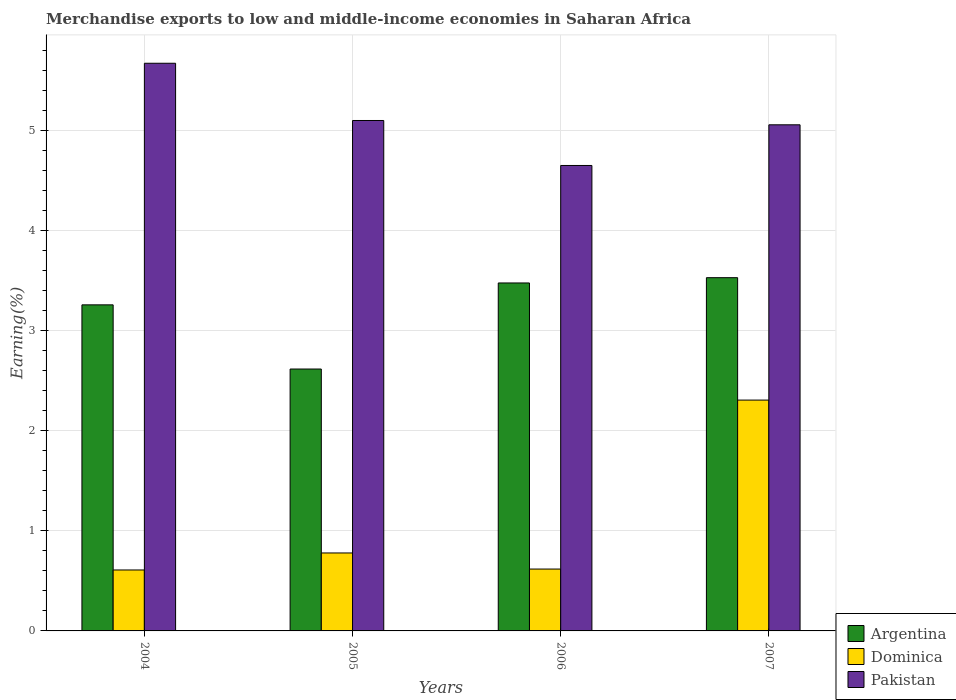How many different coloured bars are there?
Provide a succinct answer. 3. Are the number of bars per tick equal to the number of legend labels?
Keep it short and to the point. Yes. Are the number of bars on each tick of the X-axis equal?
Offer a very short reply. Yes. How many bars are there on the 1st tick from the left?
Your response must be concise. 3. In how many cases, is the number of bars for a given year not equal to the number of legend labels?
Provide a short and direct response. 0. What is the percentage of amount earned from merchandise exports in Pakistan in 2005?
Offer a very short reply. 5.1. Across all years, what is the maximum percentage of amount earned from merchandise exports in Pakistan?
Provide a short and direct response. 5.68. Across all years, what is the minimum percentage of amount earned from merchandise exports in Pakistan?
Your response must be concise. 4.66. In which year was the percentage of amount earned from merchandise exports in Argentina minimum?
Offer a very short reply. 2005. What is the total percentage of amount earned from merchandise exports in Pakistan in the graph?
Provide a short and direct response. 20.5. What is the difference between the percentage of amount earned from merchandise exports in Dominica in 2005 and that in 2006?
Give a very brief answer. 0.16. What is the difference between the percentage of amount earned from merchandise exports in Dominica in 2007 and the percentage of amount earned from merchandise exports in Pakistan in 2004?
Give a very brief answer. -3.37. What is the average percentage of amount earned from merchandise exports in Argentina per year?
Offer a terse response. 3.22. In the year 2007, what is the difference between the percentage of amount earned from merchandise exports in Pakistan and percentage of amount earned from merchandise exports in Argentina?
Give a very brief answer. 1.53. What is the ratio of the percentage of amount earned from merchandise exports in Dominica in 2005 to that in 2006?
Your answer should be very brief. 1.26. What is the difference between the highest and the second highest percentage of amount earned from merchandise exports in Pakistan?
Provide a succinct answer. 0.57. What is the difference between the highest and the lowest percentage of amount earned from merchandise exports in Argentina?
Provide a short and direct response. 0.91. Is the sum of the percentage of amount earned from merchandise exports in Pakistan in 2005 and 2007 greater than the maximum percentage of amount earned from merchandise exports in Argentina across all years?
Ensure brevity in your answer.  Yes. What does the 2nd bar from the left in 2007 represents?
Ensure brevity in your answer.  Dominica. What does the 1st bar from the right in 2007 represents?
Keep it short and to the point. Pakistan. Is it the case that in every year, the sum of the percentage of amount earned from merchandise exports in Dominica and percentage of amount earned from merchandise exports in Pakistan is greater than the percentage of amount earned from merchandise exports in Argentina?
Offer a very short reply. Yes. How many bars are there?
Offer a very short reply. 12. Are all the bars in the graph horizontal?
Provide a short and direct response. No. What is the difference between two consecutive major ticks on the Y-axis?
Offer a terse response. 1. Does the graph contain any zero values?
Offer a terse response. No. Does the graph contain grids?
Provide a succinct answer. Yes. How many legend labels are there?
Ensure brevity in your answer.  3. How are the legend labels stacked?
Ensure brevity in your answer.  Vertical. What is the title of the graph?
Keep it short and to the point. Merchandise exports to low and middle-income economies in Saharan Africa. Does "Spain" appear as one of the legend labels in the graph?
Ensure brevity in your answer.  No. What is the label or title of the Y-axis?
Give a very brief answer. Earning(%). What is the Earning(%) of Argentina in 2004?
Give a very brief answer. 3.26. What is the Earning(%) of Dominica in 2004?
Your response must be concise. 0.61. What is the Earning(%) of Pakistan in 2004?
Provide a short and direct response. 5.68. What is the Earning(%) in Argentina in 2005?
Your answer should be very brief. 2.62. What is the Earning(%) of Dominica in 2005?
Offer a terse response. 0.78. What is the Earning(%) of Pakistan in 2005?
Give a very brief answer. 5.1. What is the Earning(%) of Argentina in 2006?
Offer a very short reply. 3.48. What is the Earning(%) of Dominica in 2006?
Make the answer very short. 0.62. What is the Earning(%) of Pakistan in 2006?
Give a very brief answer. 4.66. What is the Earning(%) in Argentina in 2007?
Give a very brief answer. 3.53. What is the Earning(%) in Dominica in 2007?
Keep it short and to the point. 2.31. What is the Earning(%) in Pakistan in 2007?
Your answer should be compact. 5.06. Across all years, what is the maximum Earning(%) of Argentina?
Ensure brevity in your answer.  3.53. Across all years, what is the maximum Earning(%) of Dominica?
Ensure brevity in your answer.  2.31. Across all years, what is the maximum Earning(%) of Pakistan?
Keep it short and to the point. 5.68. Across all years, what is the minimum Earning(%) in Argentina?
Provide a succinct answer. 2.62. Across all years, what is the minimum Earning(%) in Dominica?
Your response must be concise. 0.61. Across all years, what is the minimum Earning(%) in Pakistan?
Your answer should be compact. 4.66. What is the total Earning(%) of Argentina in the graph?
Ensure brevity in your answer.  12.89. What is the total Earning(%) in Dominica in the graph?
Provide a short and direct response. 4.32. What is the total Earning(%) in Pakistan in the graph?
Your response must be concise. 20.5. What is the difference between the Earning(%) in Argentina in 2004 and that in 2005?
Make the answer very short. 0.64. What is the difference between the Earning(%) in Dominica in 2004 and that in 2005?
Make the answer very short. -0.17. What is the difference between the Earning(%) of Pakistan in 2004 and that in 2005?
Your answer should be very brief. 0.57. What is the difference between the Earning(%) of Argentina in 2004 and that in 2006?
Ensure brevity in your answer.  -0.22. What is the difference between the Earning(%) of Dominica in 2004 and that in 2006?
Your answer should be compact. -0.01. What is the difference between the Earning(%) in Pakistan in 2004 and that in 2006?
Offer a very short reply. 1.02. What is the difference between the Earning(%) of Argentina in 2004 and that in 2007?
Offer a terse response. -0.27. What is the difference between the Earning(%) of Dominica in 2004 and that in 2007?
Ensure brevity in your answer.  -1.7. What is the difference between the Earning(%) of Pakistan in 2004 and that in 2007?
Your response must be concise. 0.62. What is the difference between the Earning(%) of Argentina in 2005 and that in 2006?
Keep it short and to the point. -0.86. What is the difference between the Earning(%) in Dominica in 2005 and that in 2006?
Your answer should be very brief. 0.16. What is the difference between the Earning(%) of Pakistan in 2005 and that in 2006?
Make the answer very short. 0.45. What is the difference between the Earning(%) in Argentina in 2005 and that in 2007?
Keep it short and to the point. -0.91. What is the difference between the Earning(%) of Dominica in 2005 and that in 2007?
Provide a succinct answer. -1.53. What is the difference between the Earning(%) in Pakistan in 2005 and that in 2007?
Offer a terse response. 0.04. What is the difference between the Earning(%) in Argentina in 2006 and that in 2007?
Give a very brief answer. -0.05. What is the difference between the Earning(%) of Dominica in 2006 and that in 2007?
Keep it short and to the point. -1.69. What is the difference between the Earning(%) in Pakistan in 2006 and that in 2007?
Keep it short and to the point. -0.41. What is the difference between the Earning(%) in Argentina in 2004 and the Earning(%) in Dominica in 2005?
Your answer should be very brief. 2.48. What is the difference between the Earning(%) in Argentina in 2004 and the Earning(%) in Pakistan in 2005?
Give a very brief answer. -1.84. What is the difference between the Earning(%) of Dominica in 2004 and the Earning(%) of Pakistan in 2005?
Your response must be concise. -4.5. What is the difference between the Earning(%) of Argentina in 2004 and the Earning(%) of Dominica in 2006?
Ensure brevity in your answer.  2.64. What is the difference between the Earning(%) in Argentina in 2004 and the Earning(%) in Pakistan in 2006?
Your answer should be compact. -1.39. What is the difference between the Earning(%) of Dominica in 2004 and the Earning(%) of Pakistan in 2006?
Offer a terse response. -4.05. What is the difference between the Earning(%) of Argentina in 2004 and the Earning(%) of Dominica in 2007?
Make the answer very short. 0.95. What is the difference between the Earning(%) of Argentina in 2004 and the Earning(%) of Pakistan in 2007?
Offer a terse response. -1.8. What is the difference between the Earning(%) in Dominica in 2004 and the Earning(%) in Pakistan in 2007?
Provide a succinct answer. -4.45. What is the difference between the Earning(%) of Argentina in 2005 and the Earning(%) of Dominica in 2006?
Your response must be concise. 2. What is the difference between the Earning(%) of Argentina in 2005 and the Earning(%) of Pakistan in 2006?
Your answer should be compact. -2.04. What is the difference between the Earning(%) of Dominica in 2005 and the Earning(%) of Pakistan in 2006?
Give a very brief answer. -3.88. What is the difference between the Earning(%) in Argentina in 2005 and the Earning(%) in Dominica in 2007?
Your answer should be compact. 0.31. What is the difference between the Earning(%) of Argentina in 2005 and the Earning(%) of Pakistan in 2007?
Your answer should be very brief. -2.44. What is the difference between the Earning(%) in Dominica in 2005 and the Earning(%) in Pakistan in 2007?
Offer a terse response. -4.28. What is the difference between the Earning(%) of Argentina in 2006 and the Earning(%) of Dominica in 2007?
Provide a short and direct response. 1.17. What is the difference between the Earning(%) in Argentina in 2006 and the Earning(%) in Pakistan in 2007?
Your answer should be very brief. -1.58. What is the difference between the Earning(%) of Dominica in 2006 and the Earning(%) of Pakistan in 2007?
Provide a short and direct response. -4.44. What is the average Earning(%) in Argentina per year?
Provide a succinct answer. 3.22. What is the average Earning(%) in Dominica per year?
Offer a terse response. 1.08. What is the average Earning(%) in Pakistan per year?
Offer a terse response. 5.12. In the year 2004, what is the difference between the Earning(%) in Argentina and Earning(%) in Dominica?
Keep it short and to the point. 2.65. In the year 2004, what is the difference between the Earning(%) in Argentina and Earning(%) in Pakistan?
Ensure brevity in your answer.  -2.42. In the year 2004, what is the difference between the Earning(%) of Dominica and Earning(%) of Pakistan?
Your answer should be compact. -5.07. In the year 2005, what is the difference between the Earning(%) of Argentina and Earning(%) of Dominica?
Your answer should be compact. 1.84. In the year 2005, what is the difference between the Earning(%) in Argentina and Earning(%) in Pakistan?
Give a very brief answer. -2.49. In the year 2005, what is the difference between the Earning(%) in Dominica and Earning(%) in Pakistan?
Your response must be concise. -4.33. In the year 2006, what is the difference between the Earning(%) in Argentina and Earning(%) in Dominica?
Your response must be concise. 2.86. In the year 2006, what is the difference between the Earning(%) in Argentina and Earning(%) in Pakistan?
Keep it short and to the point. -1.18. In the year 2006, what is the difference between the Earning(%) of Dominica and Earning(%) of Pakistan?
Keep it short and to the point. -4.04. In the year 2007, what is the difference between the Earning(%) in Argentina and Earning(%) in Dominica?
Provide a succinct answer. 1.22. In the year 2007, what is the difference between the Earning(%) of Argentina and Earning(%) of Pakistan?
Provide a short and direct response. -1.53. In the year 2007, what is the difference between the Earning(%) of Dominica and Earning(%) of Pakistan?
Provide a succinct answer. -2.75. What is the ratio of the Earning(%) of Argentina in 2004 to that in 2005?
Your answer should be very brief. 1.25. What is the ratio of the Earning(%) of Dominica in 2004 to that in 2005?
Provide a short and direct response. 0.78. What is the ratio of the Earning(%) in Pakistan in 2004 to that in 2005?
Give a very brief answer. 1.11. What is the ratio of the Earning(%) in Argentina in 2004 to that in 2006?
Keep it short and to the point. 0.94. What is the ratio of the Earning(%) of Dominica in 2004 to that in 2006?
Your response must be concise. 0.98. What is the ratio of the Earning(%) in Pakistan in 2004 to that in 2006?
Provide a succinct answer. 1.22. What is the ratio of the Earning(%) of Dominica in 2004 to that in 2007?
Give a very brief answer. 0.26. What is the ratio of the Earning(%) in Pakistan in 2004 to that in 2007?
Make the answer very short. 1.12. What is the ratio of the Earning(%) of Argentina in 2005 to that in 2006?
Make the answer very short. 0.75. What is the ratio of the Earning(%) of Dominica in 2005 to that in 2006?
Provide a succinct answer. 1.26. What is the ratio of the Earning(%) of Pakistan in 2005 to that in 2006?
Provide a short and direct response. 1.1. What is the ratio of the Earning(%) in Argentina in 2005 to that in 2007?
Give a very brief answer. 0.74. What is the ratio of the Earning(%) of Dominica in 2005 to that in 2007?
Your response must be concise. 0.34. What is the ratio of the Earning(%) of Pakistan in 2005 to that in 2007?
Offer a very short reply. 1.01. What is the ratio of the Earning(%) in Argentina in 2006 to that in 2007?
Keep it short and to the point. 0.99. What is the ratio of the Earning(%) in Dominica in 2006 to that in 2007?
Your answer should be very brief. 0.27. What is the ratio of the Earning(%) in Pakistan in 2006 to that in 2007?
Provide a short and direct response. 0.92. What is the difference between the highest and the second highest Earning(%) of Argentina?
Provide a short and direct response. 0.05. What is the difference between the highest and the second highest Earning(%) of Dominica?
Provide a short and direct response. 1.53. What is the difference between the highest and the second highest Earning(%) of Pakistan?
Your answer should be compact. 0.57. What is the difference between the highest and the lowest Earning(%) in Argentina?
Offer a terse response. 0.91. What is the difference between the highest and the lowest Earning(%) of Dominica?
Provide a succinct answer. 1.7. What is the difference between the highest and the lowest Earning(%) of Pakistan?
Make the answer very short. 1.02. 